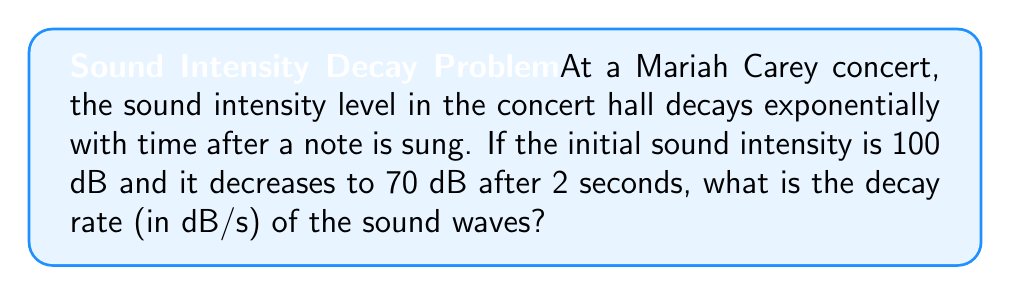Give your solution to this math problem. Let's approach this step-by-step:

1) The exponential decay function for sound intensity can be expressed as:
   $$I(t) = I_0 e^{-kt}$$
   where $I(t)$ is the intensity at time $t$, $I_0$ is the initial intensity, and $k$ is the decay constant.

2) We're given:
   $I_0 = 100$ dB
   $I(2) = 70$ dB
   $t = 2$ seconds

3) Substituting these values into the equation:
   $$70 = 100 e^{-k(2)}$$

4) Dividing both sides by 100:
   $$0.7 = e^{-2k}$$

5) Taking the natural logarithm of both sides:
   $$\ln(0.7) = -2k$$

6) Solving for $k$:
   $$k = -\frac{\ln(0.7)}{2} \approx 0.1783$$

7) The decay rate is the change in intensity per unit time. In this case, it's the decay constant multiplied by the initial intensity:
   Decay rate $= k \cdot I_0 = 0.1783 \cdot 100 \approx 17.83$ dB/s

Therefore, the sound waves decay at a rate of approximately 17.83 dB per second.
Answer: 17.83 dB/s 